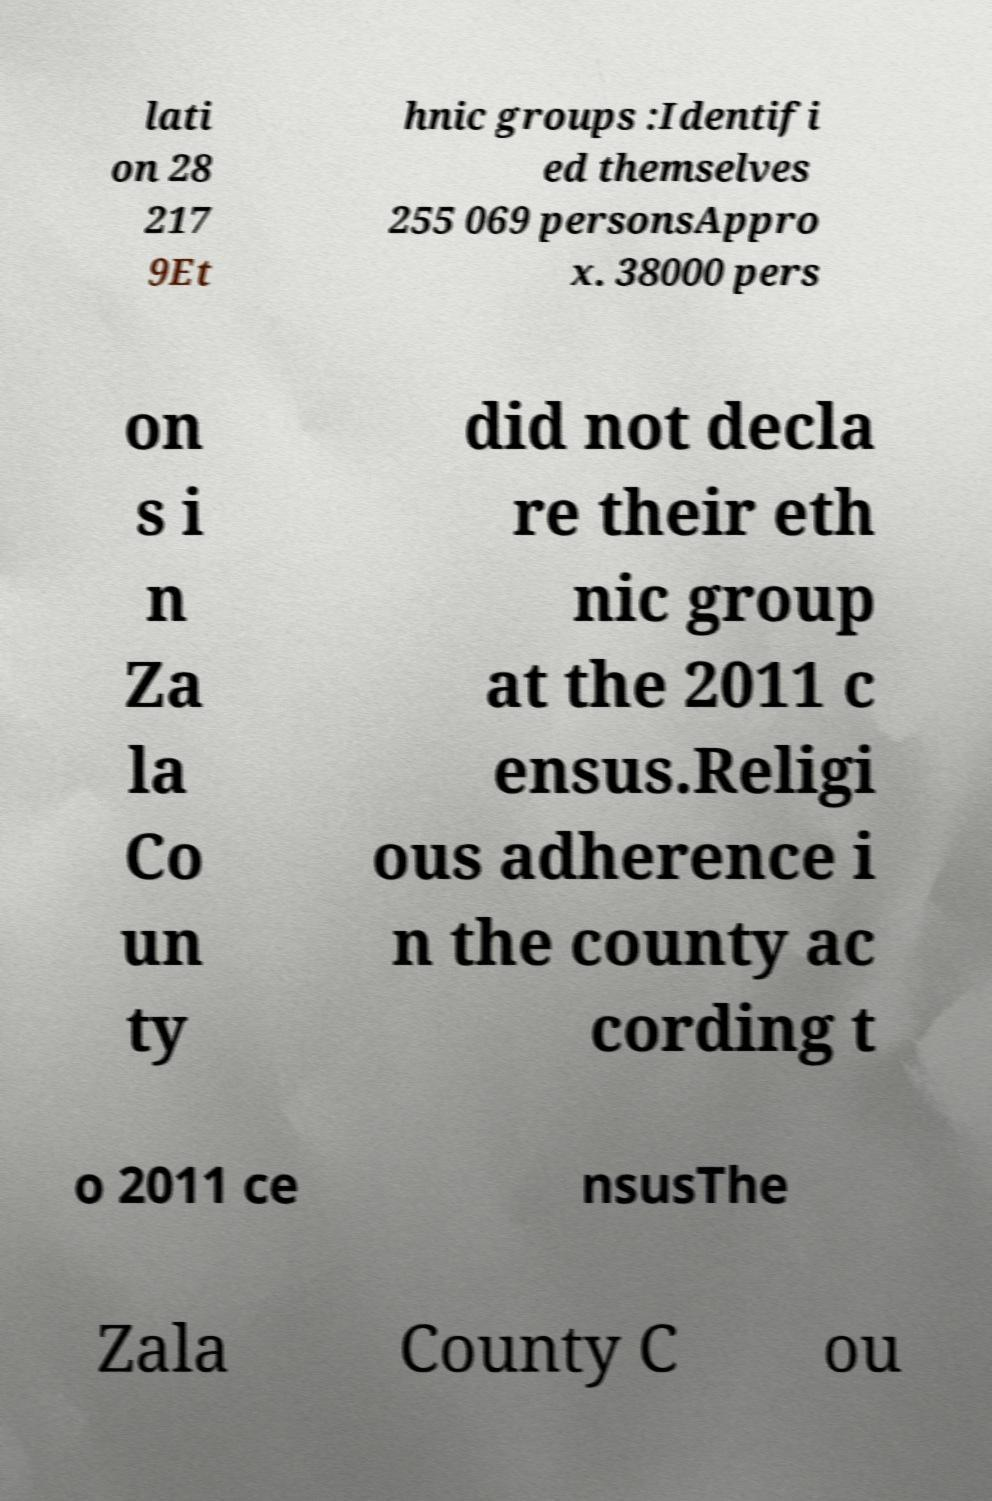Can you read and provide the text displayed in the image?This photo seems to have some interesting text. Can you extract and type it out for me? lati on 28 217 9Et hnic groups :Identifi ed themselves 255 069 personsAppro x. 38000 pers on s i n Za la Co un ty did not decla re their eth nic group at the 2011 c ensus.Religi ous adherence i n the county ac cording t o 2011 ce nsusThe Zala County C ou 